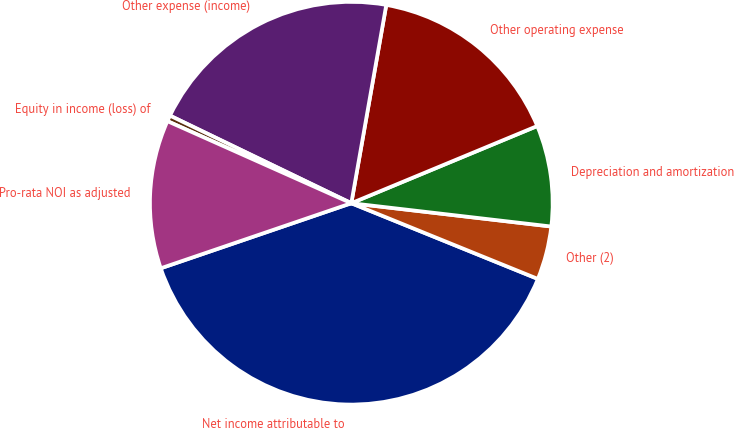Convert chart to OTSL. <chart><loc_0><loc_0><loc_500><loc_500><pie_chart><fcel>Net income attributable to<fcel>Other (2)<fcel>Depreciation and amortization<fcel>Other operating expense<fcel>Other expense (income)<fcel>Equity in income (loss) of<fcel>Pro-rata NOI as adjusted<nl><fcel>38.63%<fcel>4.29%<fcel>8.11%<fcel>15.96%<fcel>20.62%<fcel>0.48%<fcel>11.92%<nl></chart> 